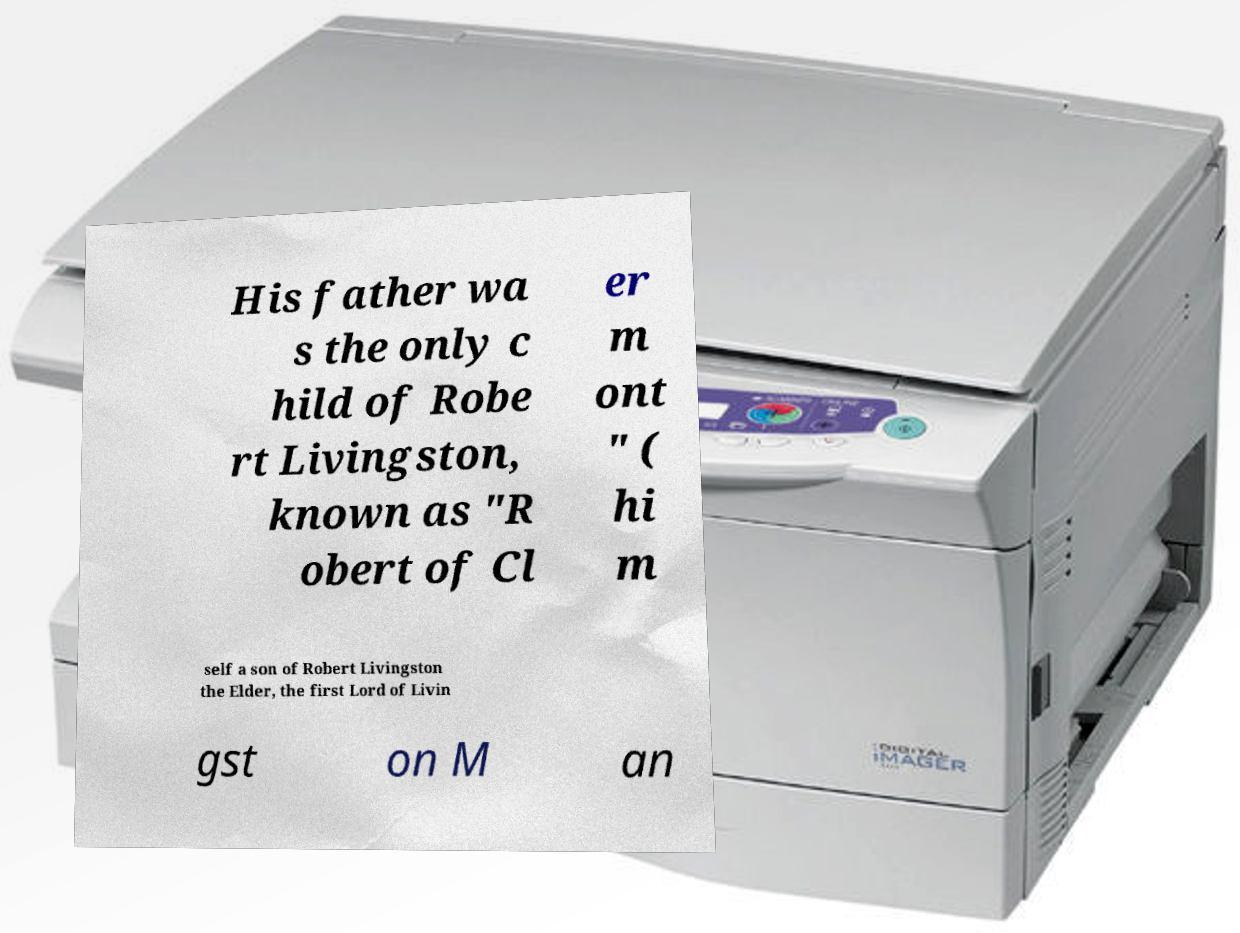What messages or text are displayed in this image? I need them in a readable, typed format. His father wa s the only c hild of Robe rt Livingston, known as "R obert of Cl er m ont " ( hi m self a son of Robert Livingston the Elder, the first Lord of Livin gst on M an 